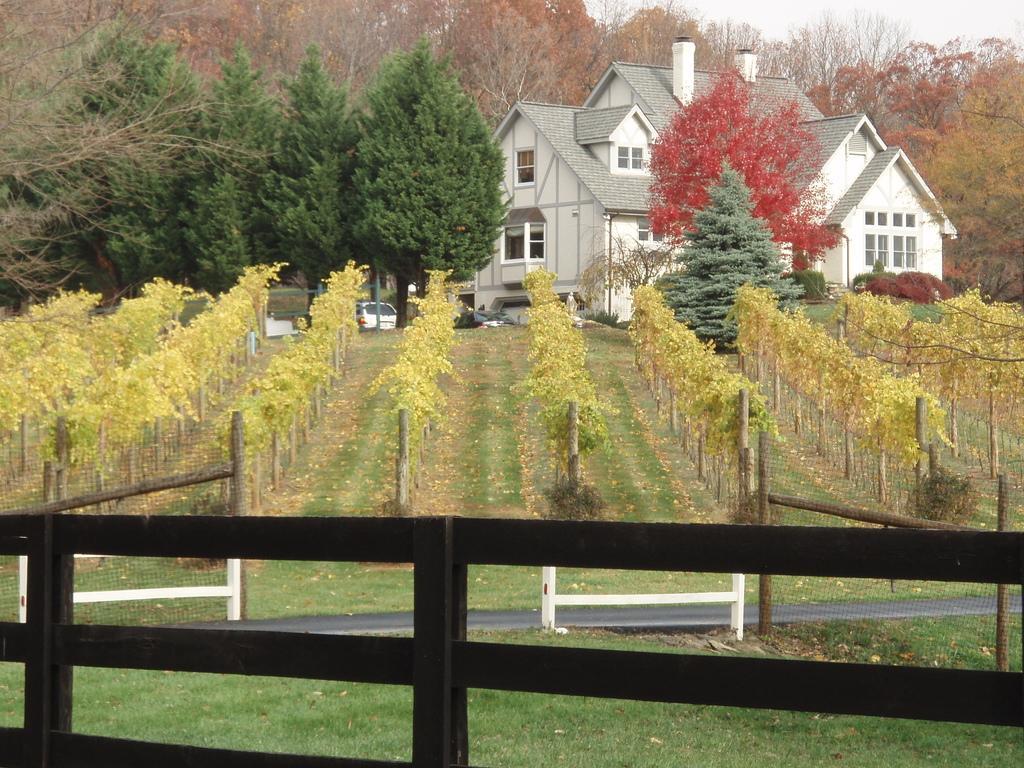Please provide a concise description of this image. In this picture we can see the grass, fences, plants, vehicles, trees, building with windows and in the background we can see the sky. 